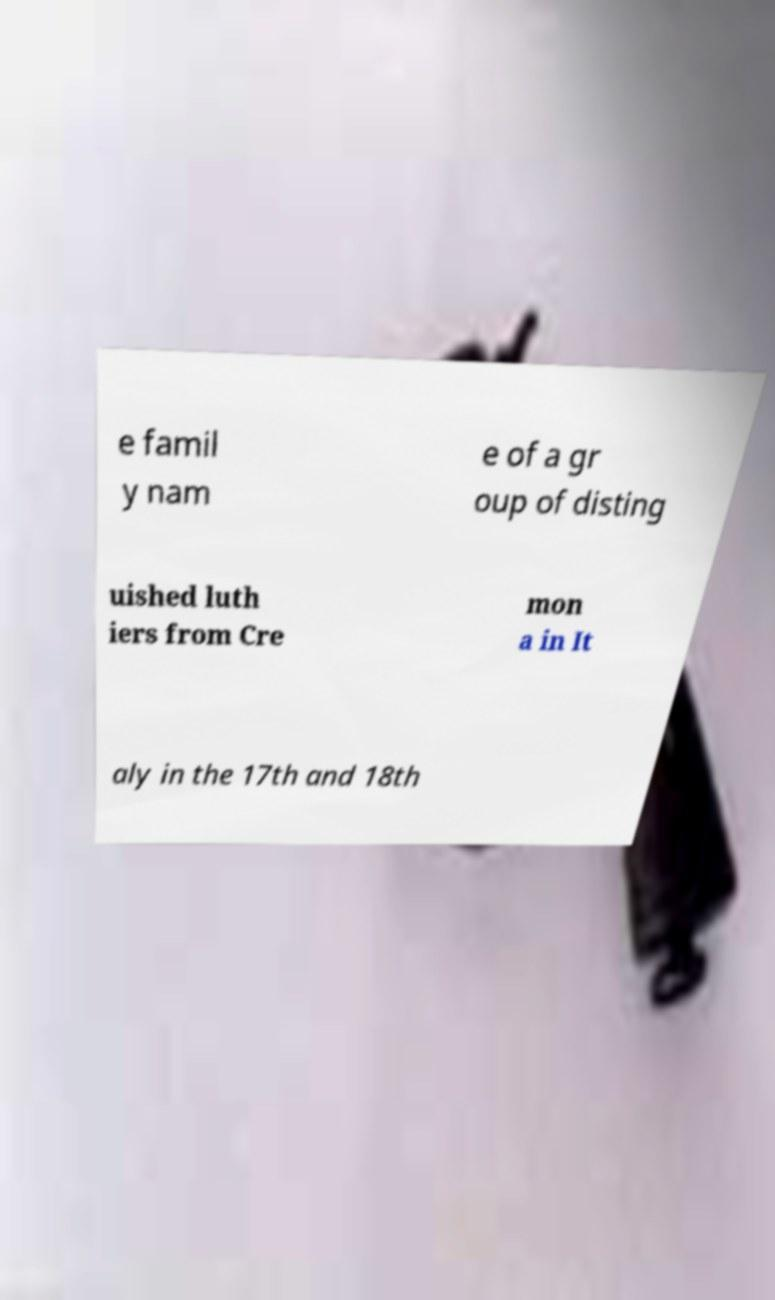Can you accurately transcribe the text from the provided image for me? e famil y nam e of a gr oup of disting uished luth iers from Cre mon a in It aly in the 17th and 18th 